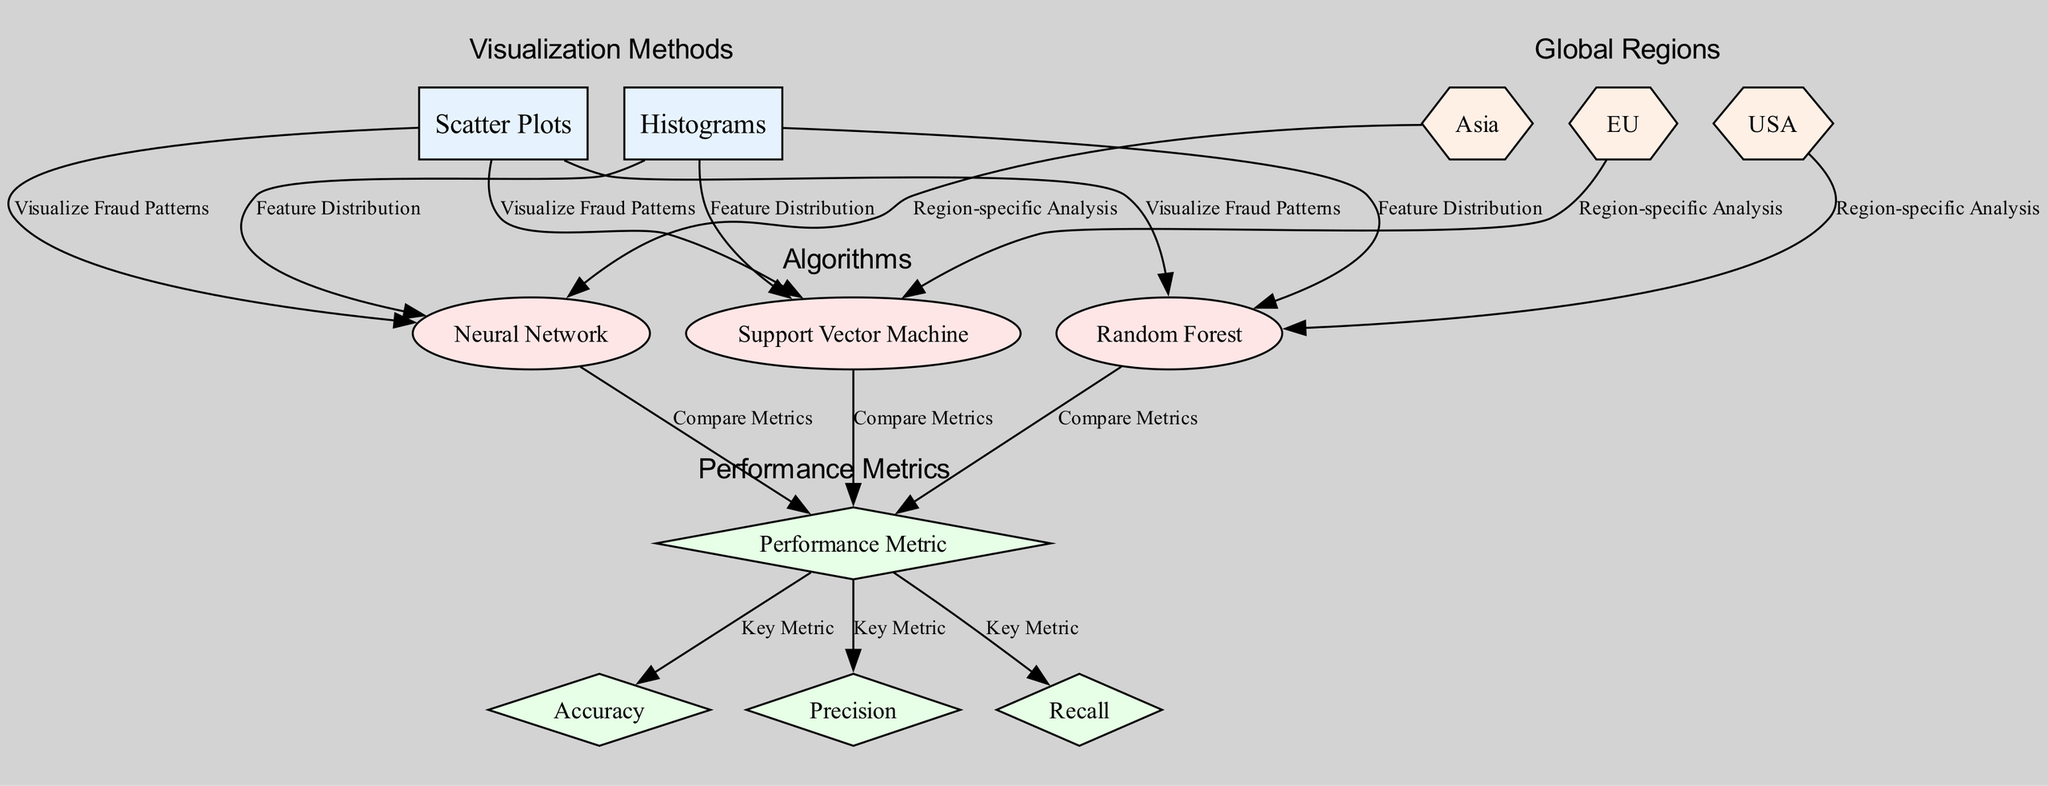What are the visualization methods used in the analysis? The diagram identifies two visualization methods: "Scatter Plots" and "Histograms". These are the first two nodes connected to various algorithms, indicating the forms of data representation employed.
Answer: Scatter Plots, Histograms How many algorithms are shown in the diagram? The diagram includes three techniques: "Random Forest", "Support Vector Machine", and "Neural Network". This is determined by counting the technique nodes linked to the visualization methods.
Answer: 3 What performance metric is associated with the algorithms? The diagram specifies three key performance metrics: "Accuracy", "Precision", and "Recall", which are connected to the "Performance Metric" node.
Answer: Accuracy, Precision, Recall Which region is associated with the Random Forest algorithm? The diagram links the "Random Forest" algorithm to the "USA", indicating a region-specific analysis for this technique.
Answer: USA What is the primary purpose of scatter plots in this analysis? The edge labeled "Visualize Fraud Patterns" between "Scatter Plots" and the algorithms conveys that scatter plots are utilized to display and analyze fraud patterns in the data.
Answer: Visualize Fraud Patterns Which algorithm is linked to the EU region in the diagram? The diagram connects "Support Vector Machine" to "EU", suggesting that this algorithm's analysis is region-specific for the European market.
Answer: Support Vector Machine What type of relationship is shown between each algorithm and the performance metrics? Each algorithm is connected to "Performance Metric" with an edge labeled "Compare Metrics", signifying that they are being evaluated based on these metrics.
Answer: Compare Metrics Which visualization method indicates feature distribution? "Histograms" are the visualization method used to depict feature distribution, as indicated by the edges connecting this node to the algorithms.
Answer: Histograms How many edges connect the algorithms to their respective regions? There are three edges that connect each technique to a specific region (USA, EU, Asia), indicating a direct relationship for region-specific analyses for each algorithm.
Answer: 3 